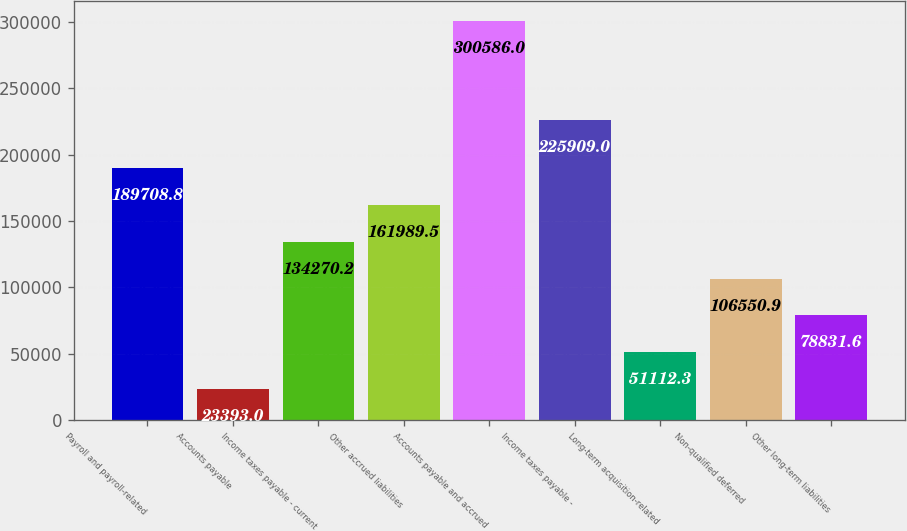<chart> <loc_0><loc_0><loc_500><loc_500><bar_chart><fcel>Payroll and payroll-related<fcel>Accounts payable<fcel>Income taxes payable - current<fcel>Other accrued liabilities<fcel>Accounts payable and accrued<fcel>Income taxes payable -<fcel>Long-term acquisition-related<fcel>Non-qualified deferred<fcel>Other long-term liabilities<nl><fcel>189709<fcel>23393<fcel>134270<fcel>161990<fcel>300586<fcel>225909<fcel>51112.3<fcel>106551<fcel>78831.6<nl></chart> 